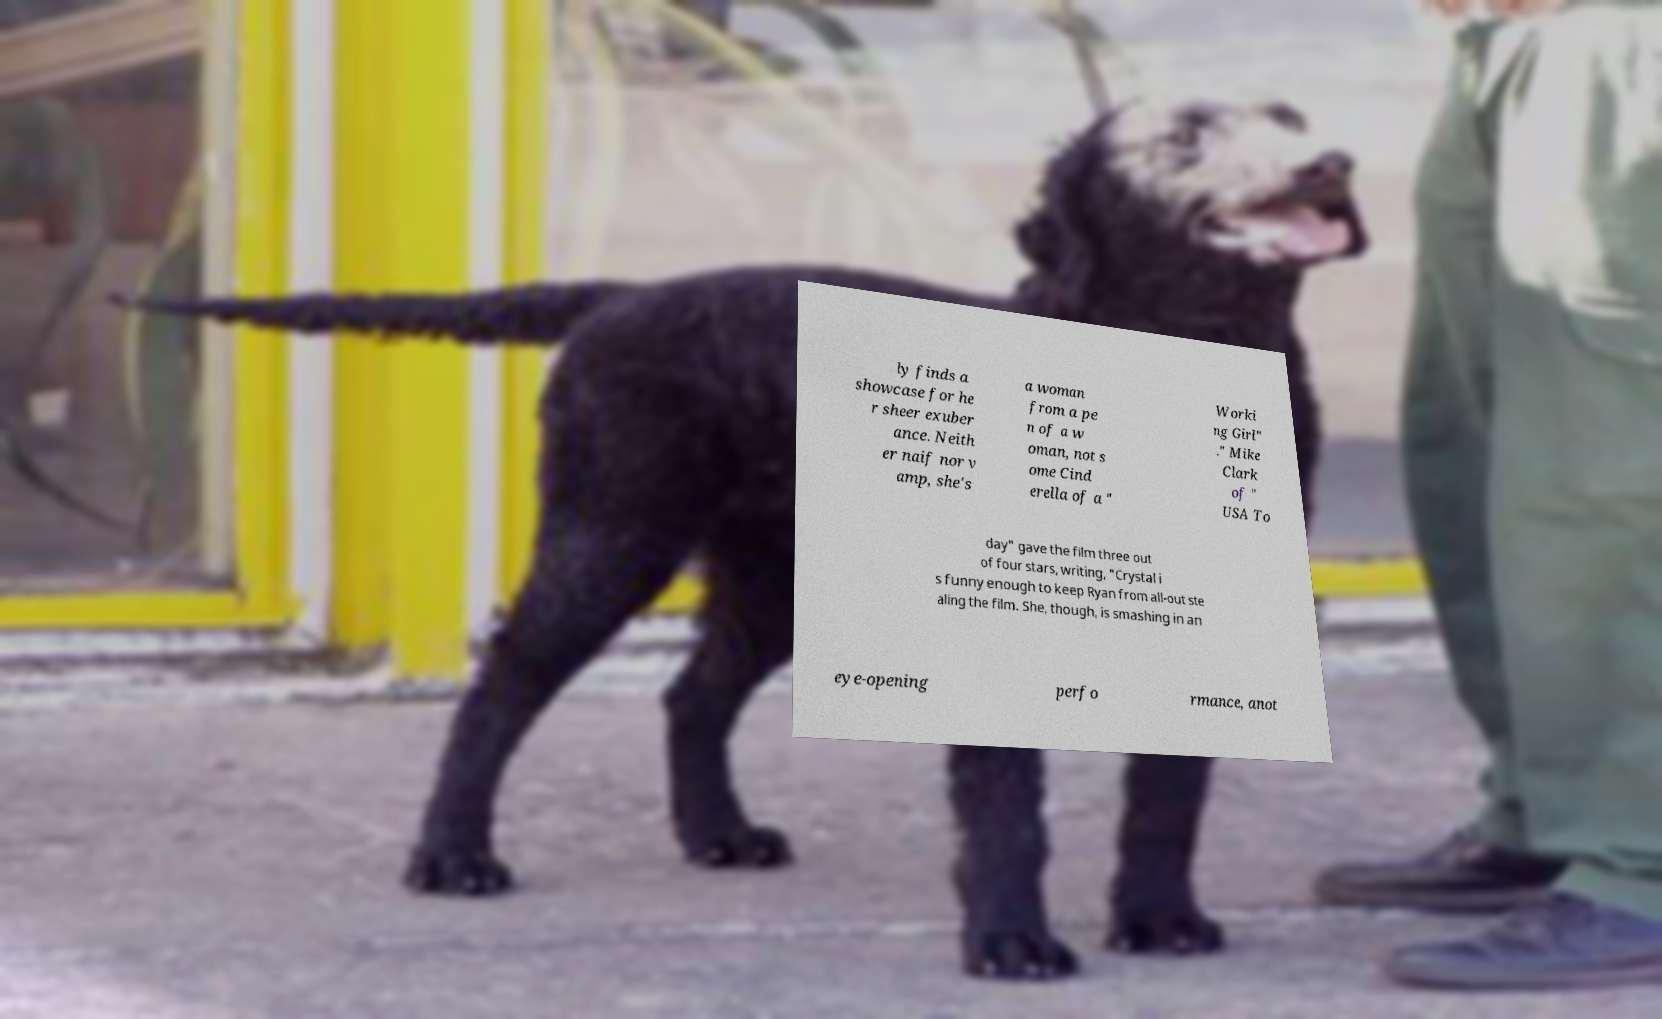What messages or text are displayed in this image? I need them in a readable, typed format. ly finds a showcase for he r sheer exuber ance. Neith er naif nor v amp, she's a woman from a pe n of a w oman, not s ome Cind erella of a " Worki ng Girl" ." Mike Clark of " USA To day" gave the film three out of four stars, writing, "Crystal i s funny enough to keep Ryan from all-out ste aling the film. She, though, is smashing in an eye-opening perfo rmance, anot 